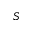<formula> <loc_0><loc_0><loc_500><loc_500>S</formula> 